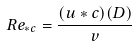Convert formula to latex. <formula><loc_0><loc_0><loc_500><loc_500>R e _ { * c } = \frac { ( u * c ) ( D ) } { v }</formula> 